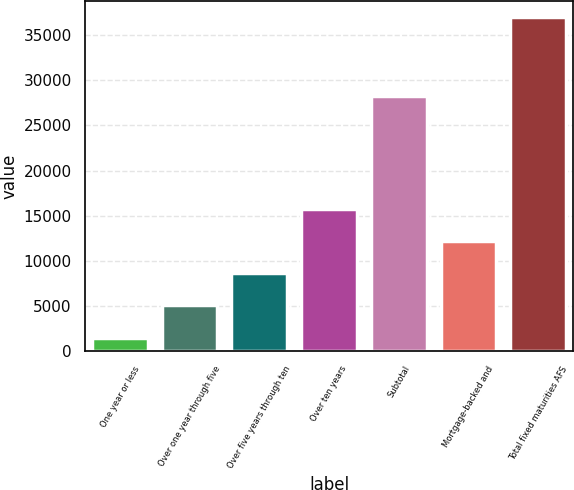<chart> <loc_0><loc_0><loc_500><loc_500><bar_chart><fcel>One year or less<fcel>Over one year through five<fcel>Over five years through ten<fcel>Over ten years<fcel>Subtotal<fcel>Mortgage-backed and<fcel>Total fixed maturities AFS<nl><fcel>1513<fcel>5119<fcel>8664.1<fcel>15754.3<fcel>28198<fcel>12209.2<fcel>36964<nl></chart> 